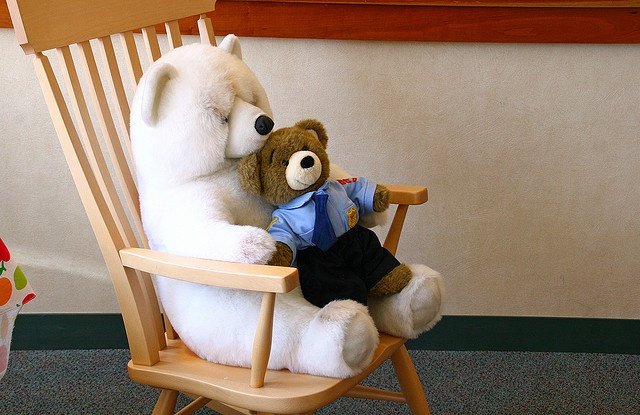Describe the objects in this image and their specific colors. I can see chair in brown, lightgray, olive, and tan tones, teddy bear in brown, lavender, darkgray, and tan tones, teddy bear in brown, black, olive, maroon, and gray tones, and tie in brown, navy, black, and darkblue tones in this image. 